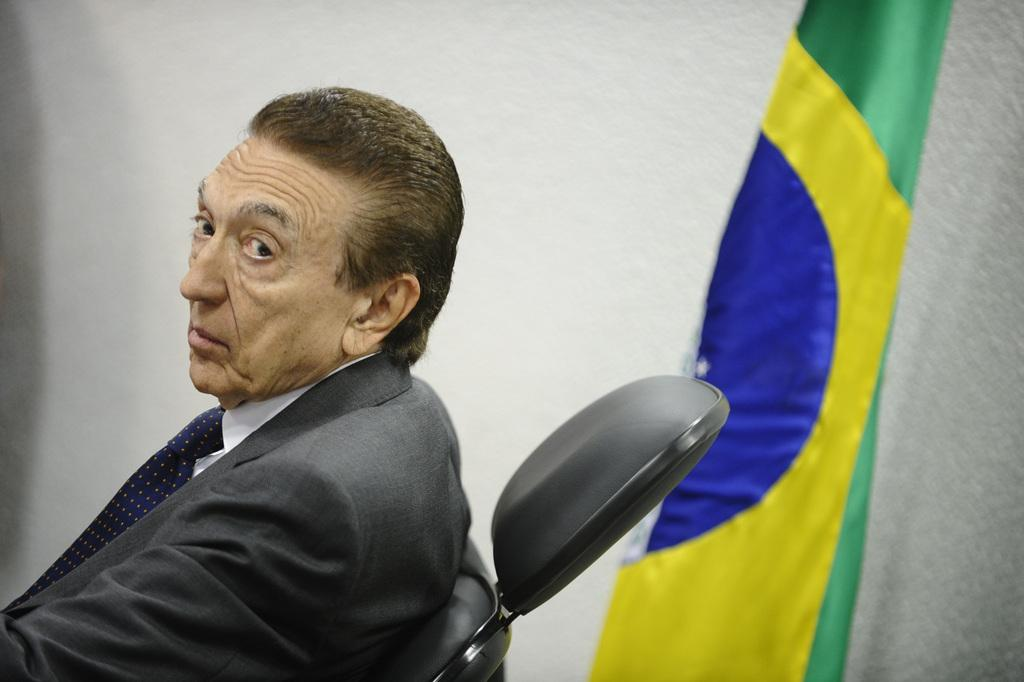What can be inferred about the location of the image? The image was likely taken indoors. What is located on the right side of the image? There is a flag and a wall on the right side of the image. Who is present in the image? There is a man in the image. What is the man wearing? The man is wearing a suit and a blue tie. What is the man's position in the image? The man is sitting on a chair. What type of education is the man receiving in the image? There is no indication in the image that the man is receiving any education. What is the man eating for lunch in the image? There is no food visible in the image, so it cannot be determined what the man might be eating for lunch. 